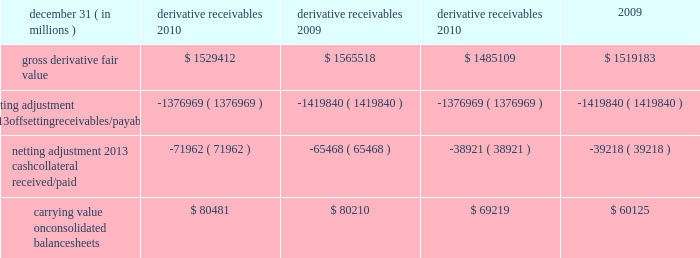Jpmorgan chase & co./2010 annual report 197 the table shows the current credit risk of derivative receivables after netting adjustments , and the current liquidity risk of derivative payables after netting adjustments , as of december 31 , 2010 and 2009. .
In addition to the collateral amounts reflected in the table above , at december 31 , 2010 and 2009 , the firm had received liquid securi- ties and other cash collateral in the amount of $ 16.5 billion and $ 15.5 billion , respectively , and had posted $ 10.9 billion and $ 11.7 billion , respectively .
The firm also receives and delivers collateral at the initiation of derivative transactions , which is available as secu- rity against potential exposure that could arise should the fair value of the transactions move in the firm 2019s or client 2019s favor , respectively .
Furthermore , the firm and its counterparties hold collateral related to contracts that have a non-daily call frequency for collateral to be posted , and collateral that the firm or a counterparty has agreed to return but has not yet settled as of the reporting date .
At december 31 , 2010 and 2009 , the firm had received $ 18.0 billion and $ 16.9 billion , respectively , and delivered $ 8.4 billion and $ 5.8 billion , respectively , of such additional collateral .
These amounts were not netted against the derivative receivables and payables in the table above , because , at an individual counterparty level , the collateral exceeded the fair value exposure at december 31 , 2010 and 2009 .
Credit derivatives credit derivatives are financial instruments whose value is derived from the credit risk associated with the debt of a third-party issuer ( the reference entity ) and which allow one party ( the protection purchaser ) to transfer that risk to another party ( the protection seller ) .
Credit derivatives expose the protection purchaser to the creditworthiness of the protection seller , as the protection seller is required to make payments under the contract when the reference entity experiences a credit event , such as a bankruptcy , a failure to pay its obligation or a restructuring .
The seller of credit protection receives a premium for providing protection but has the risk that the underlying instrument referenced in the contract will be subject to a credit event .
The firm is both a purchaser and seller of protection in the credit derivatives market and uses these derivatives for two primary purposes .
First , in its capacity as a market-maker in the dealer/client business , the firm actively risk manages a portfolio of credit derivatives by purchasing and selling credit protection , pre- dominantly on corporate debt obligations , to meet the needs of customers .
As a seller of protection , the firm 2019s exposure to a given reference entity may be offset partially , or entirely , with a contract to purchase protection from another counterparty on the same or similar reference entity .
Second , the firm uses credit derivatives to mitigate credit risk associated with its overall derivative receivables and traditional commercial credit lending exposures ( loans and unfunded commitments ) as well as to manage its exposure to residential and commercial mortgages .
See note 3 on pages 170 2013 187 of this annual report for further information on the firm 2019s mortgage-related exposures .
In accomplishing the above , the firm uses different types of credit derivatives .
Following is a summary of various types of credit derivatives .
Credit default swaps credit derivatives may reference the credit of either a single refer- ence entity ( 201csingle-name 201d ) or a broad-based index .
The firm purchases and sells protection on both single- name and index- reference obligations .
Single-name cds and index cds contracts are otc derivative contracts .
Single-name cds are used to manage the default risk of a single reference entity , while index cds con- tracts are used to manage the credit risk associated with the broader credit markets or credit market segments .
Like the s&p 500 and other market indices , a cds index comprises a portfolio of cds across many reference entities .
New series of cds indices are periodically established with a new underlying portfolio of reference entities to reflect changes in the credit markets .
If one of the refer- ence entities in the index experiences a credit event , then the reference entity that defaulted is removed from the index .
Cds can also be referenced against specific portfolios of reference names or against customized exposure levels based on specific client de- mands : for example , to provide protection against the first $ 1 million of realized credit losses in a $ 10 million portfolio of expo- sure .
Such structures are commonly known as tranche cds .
For both single-name cds contracts and index cds contracts , upon the occurrence of a credit event , under the terms of a cds contract neither party to the cds contract has recourse to the reference entity .
The protection purchaser has recourse to the protection seller for the difference between the face value of the cds contract and the fair value of the reference obligation at the time of settling the credit derivative contract , also known as the recovery value .
The protection purchaser does not need to hold the debt instrument of the underlying reference entity in order to receive amounts due under the cds contract when a credit event occurs .
Credit-related notes a credit-related note is a funded credit derivative where the issuer of the credit-related note purchases from the note investor credit protec- tion on a referenced entity .
Under the contract , the investor pays the issuer the par value of the note at the inception of the transaction , and in return , the issuer pays periodic payments to the investor , based on the credit risk of the referenced entity .
The issuer also repays the investor the par value of the note at maturity unless the reference entity experiences a specified credit event .
If a credit event .
In 2010 what was the ratio of the firms other cash collateral received to the amount posted? 
Computations: (16.5 / 10.9)
Answer: 1.51376. 